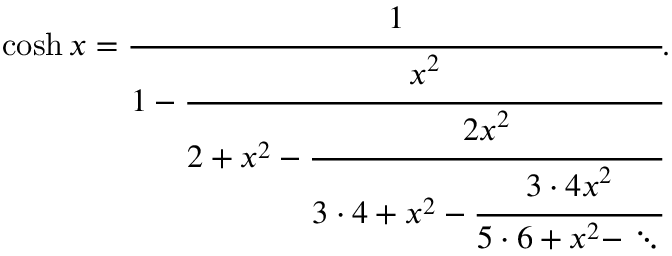<formula> <loc_0><loc_0><loc_500><loc_500>\cosh x = { \cfrac { 1 } { 1 - { \cfrac { x ^ { 2 } } { 2 + x ^ { 2 } - { \cfrac { 2 x ^ { 2 } } { 3 \cdot 4 + x ^ { 2 } - { \cfrac { 3 \cdot 4 x ^ { 2 } } { 5 \cdot 6 + x ^ { 2 } - \ddots } } } } } } } } .</formula> 